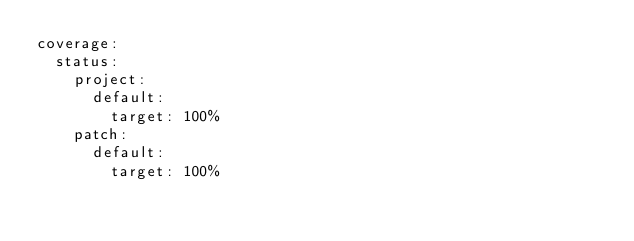<code> <loc_0><loc_0><loc_500><loc_500><_YAML_>coverage:
  status:
    project:
      default:
        target: 100%
    patch:
      default:
        target: 100%
</code> 